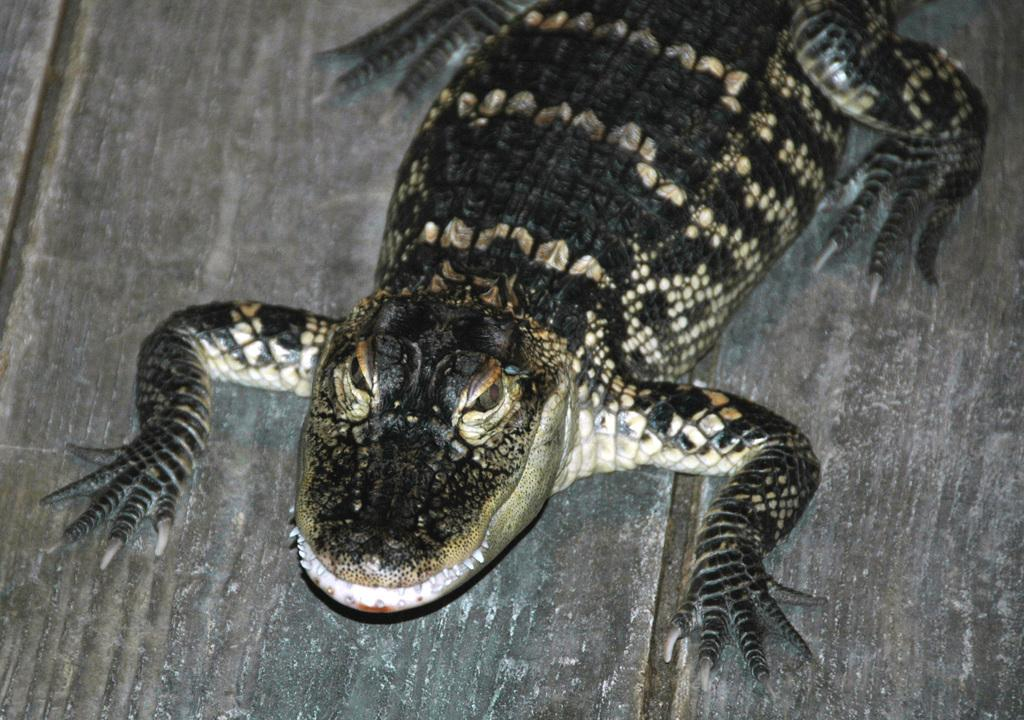What type of creature can be seen in the image? There is an animal in the image. Can you describe the surface the animal is on? The animal is on a wooden surface. What shape is the kettle on the wooden surface in the image? There is no kettle present in the image. How many oranges are visible on the wooden surface in the image? There are no oranges present in the image. 